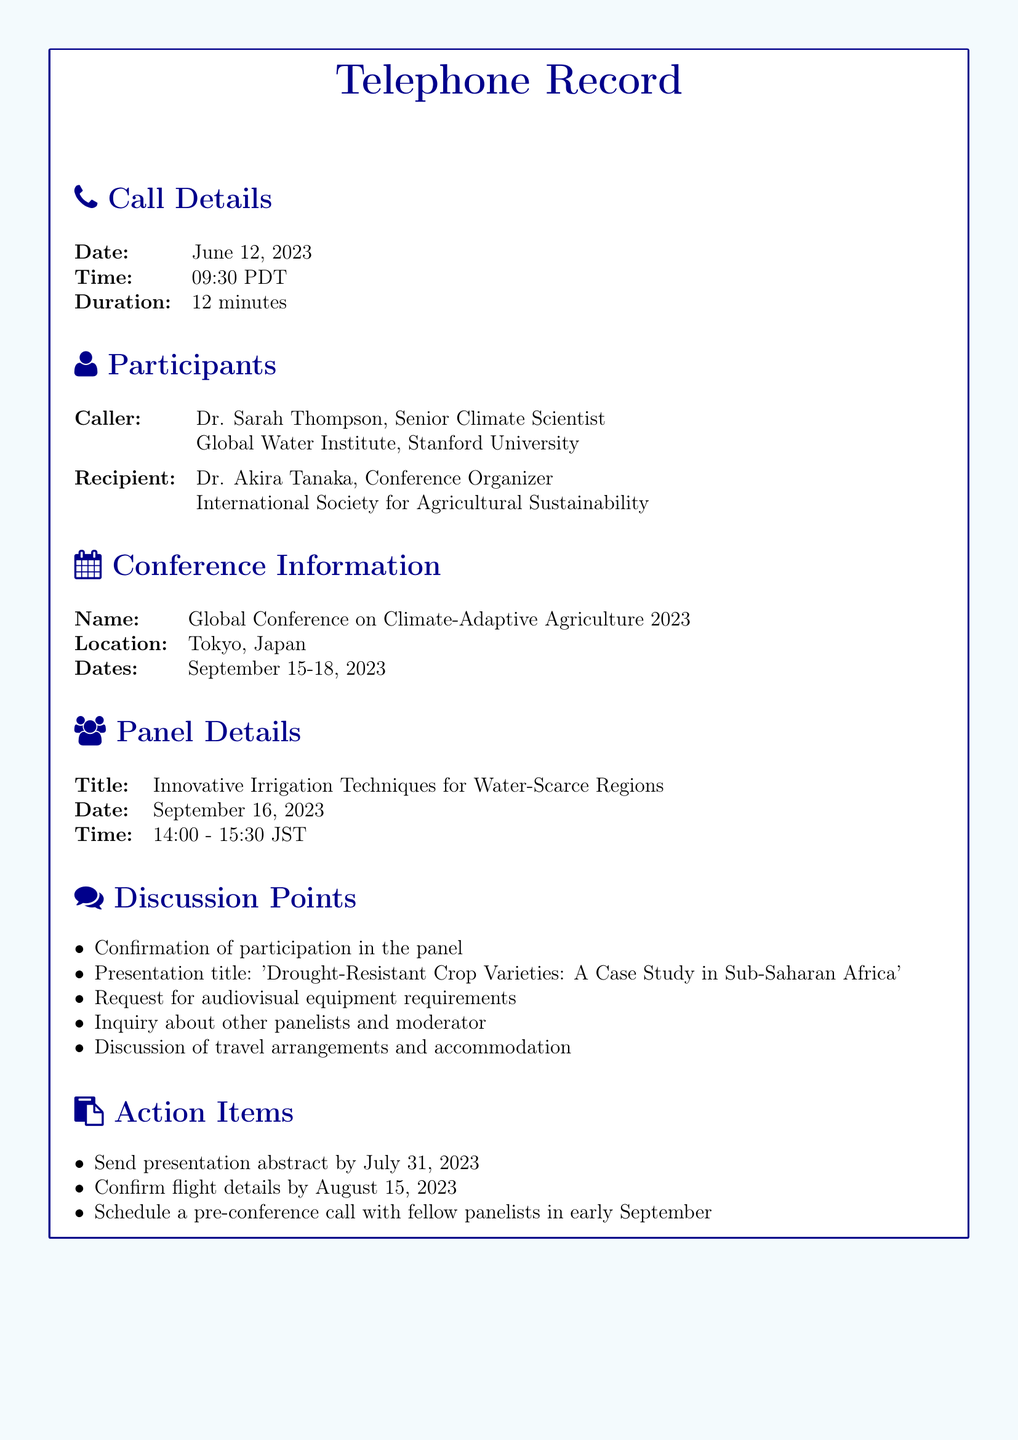What is the name of the conference? The name of the conference is provided in the document as "Global Conference on Climate-Adaptive Agriculture 2023."
Answer: Global Conference on Climate-Adaptive Agriculture 2023 Who is the caller? The document specifies that the caller is Dr. Sarah Thompson, a Senior Climate Scientist.
Answer: Dr. Sarah Thompson What is the title of the panel? The title of the panel is explicitly mentioned in the document as "Innovative Irrigation Techniques for Water-Scarce Regions."
Answer: Innovative Irrigation Techniques for Water-Scarce Regions What is the presentation title? The presentation title is outlined in the discussion points of the document as "Drought-Resistant Crop Varieties: A Case Study in Sub-Saharan Africa."
Answer: Drought-Resistant Crop Varieties: A Case Study in Sub-Saharan Africa When is the panel scheduled? The document states the panel is scheduled for September 16, 2023.
Answer: September 16, 2023 What is the duration of the call? The document provides the duration of the call as 12 minutes.
Answer: 12 minutes What do the action items involve? The action items listed require sending an abstract, confirming flight details, and scheduling a pre-conference call.
Answer: Send presentation abstract, confirm flight details, schedule pre-conference call Who is the recipient of the call? The recipient of the call is detailed in the document as Dr. Akira Tanaka, the conference organizer.
Answer: Dr. Akira Tanaka 